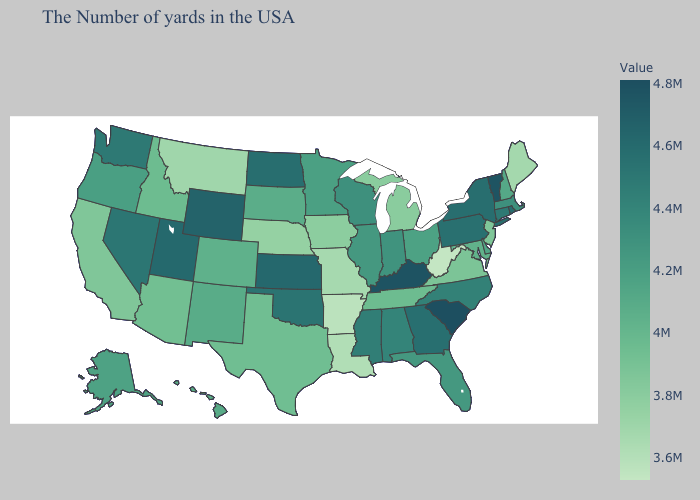Is the legend a continuous bar?
Be succinct. Yes. Does Maine have the lowest value in the Northeast?
Give a very brief answer. Yes. Does Texas have a lower value than Kentucky?
Be succinct. Yes. Which states hav the highest value in the West?
Short answer required. Wyoming. 